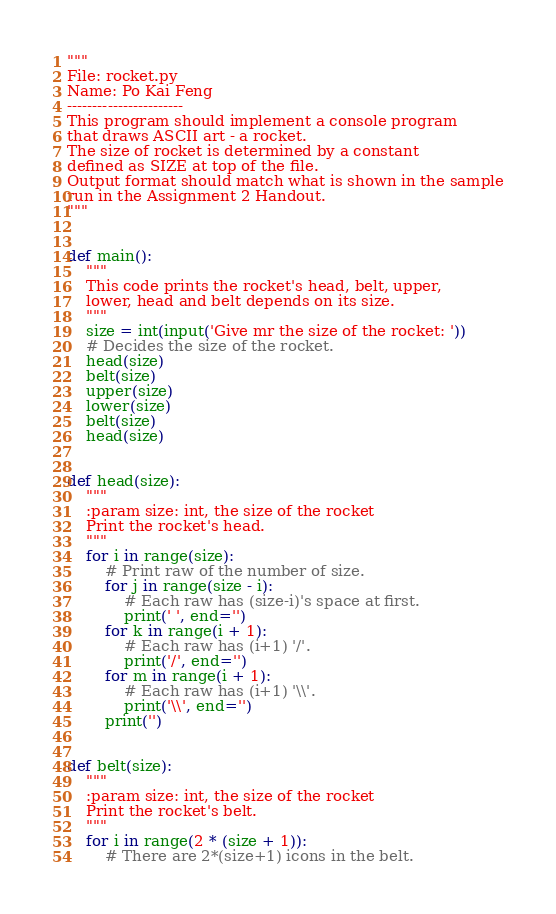<code> <loc_0><loc_0><loc_500><loc_500><_Python_>"""
File: rocket.py
Name: Po Kai Feng
-----------------------
This program should implement a console program
that draws ASCII art - a rocket.
The size of rocket is determined by a constant
defined as SIZE at top of the file.
Output format should match what is shown in the sample
run in the Assignment 2 Handout.
"""


def main():
    """
	This code prints the rocket's head, belt, upper,
	lower, head and belt depends on its size.
	"""
    size = int(input('Give mr the size of the rocket: '))
    # Decides the size of the rocket.
    head(size)
    belt(size)
    upper(size)
    lower(size)
    belt(size)
    head(size)


def head(size):
    """
	:param size: int, the size of the rocket
	Print the rocket's head.
	"""
    for i in range(size):
        # Print raw of the number of size.
        for j in range(size - i):
            # Each raw has (size-i)'s space at first.
            print(' ', end='')
        for k in range(i + 1):
            # Each raw has (i+1) '/'.
            print('/', end='')
        for m in range(i + 1):
            # Each raw has (i+1) '\\'.
            print('\\', end='')
        print('')


def belt(size):
    """
	:param size: int, the size of the rocket
	Print the rocket's belt.
	"""
    for i in range(2 * (size + 1)):
        # There are 2*(size+1) icons in the belt.</code> 